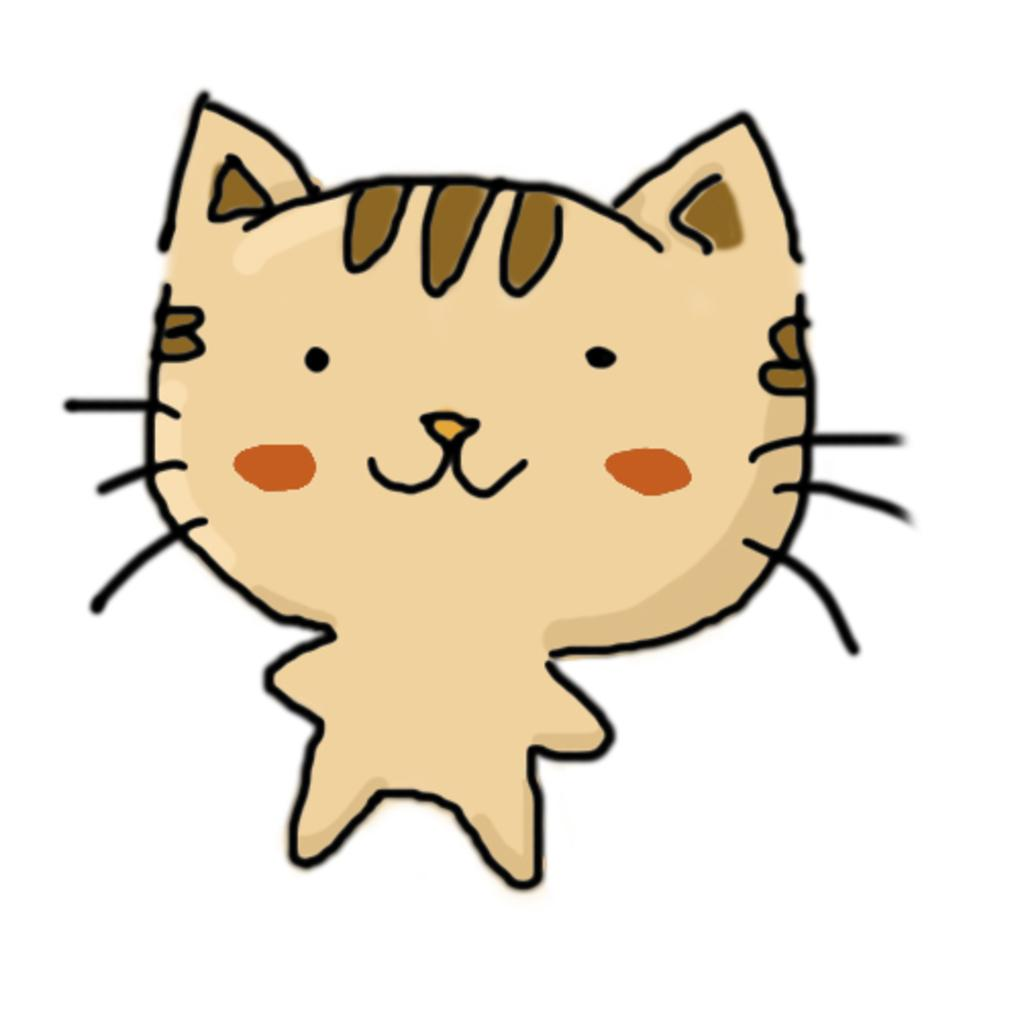What is the main subject in the center of the image? There is a cartoon in the center of the image. What type of quiver can be seen in the hands of the bears in the image? There are no bears or quivers present in the image; it only features a cartoon. 